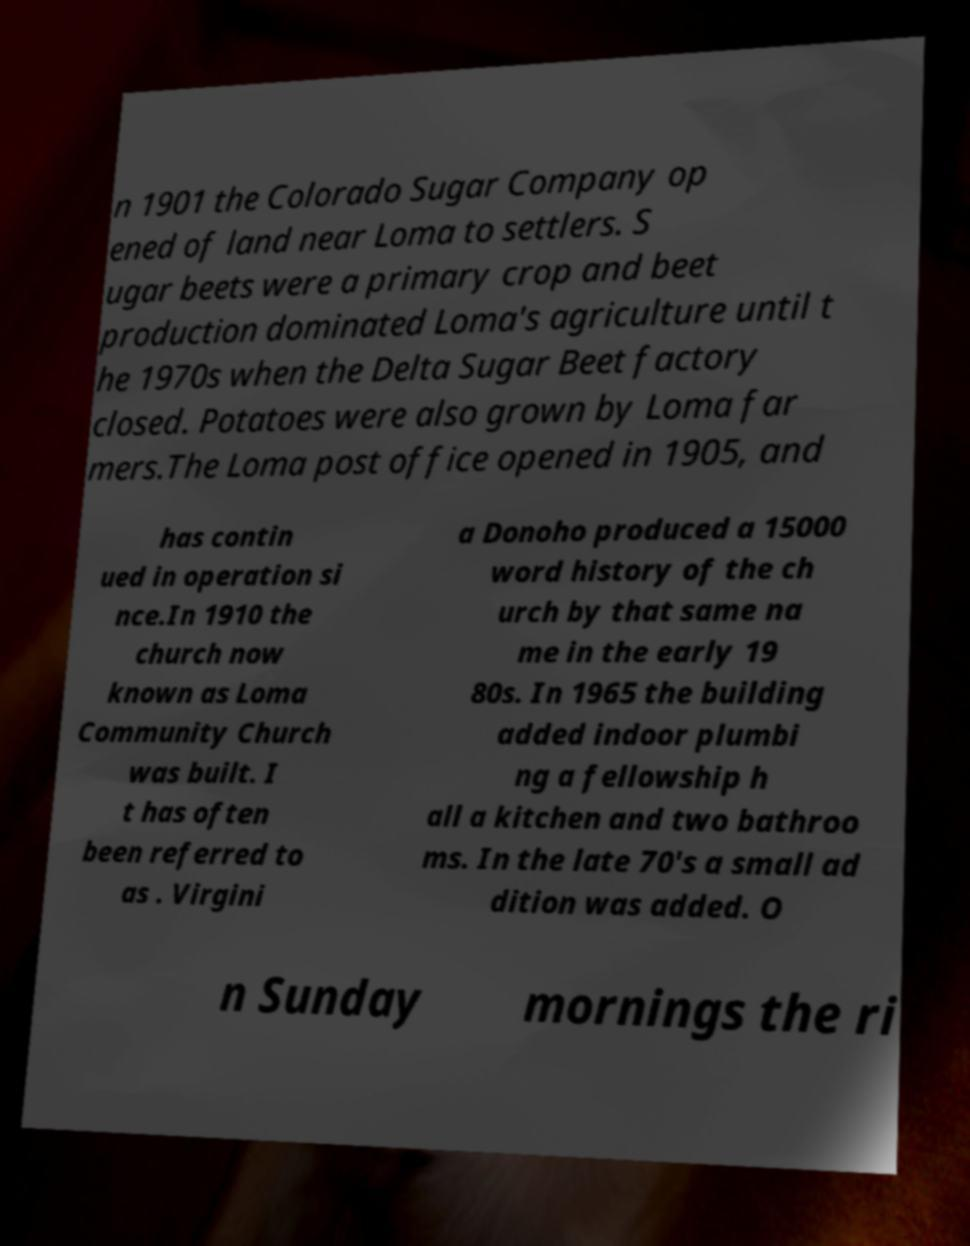Please identify and transcribe the text found in this image. n 1901 the Colorado Sugar Company op ened of land near Loma to settlers. S ugar beets were a primary crop and beet production dominated Loma's agriculture until t he 1970s when the Delta Sugar Beet factory closed. Potatoes were also grown by Loma far mers.The Loma post office opened in 1905, and has contin ued in operation si nce.In 1910 the church now known as Loma Community Church was built. I t has often been referred to as . Virgini a Donoho produced a 15000 word history of the ch urch by that same na me in the early 19 80s. In 1965 the building added indoor plumbi ng a fellowship h all a kitchen and two bathroo ms. In the late 70's a small ad dition was added. O n Sunday mornings the ri 